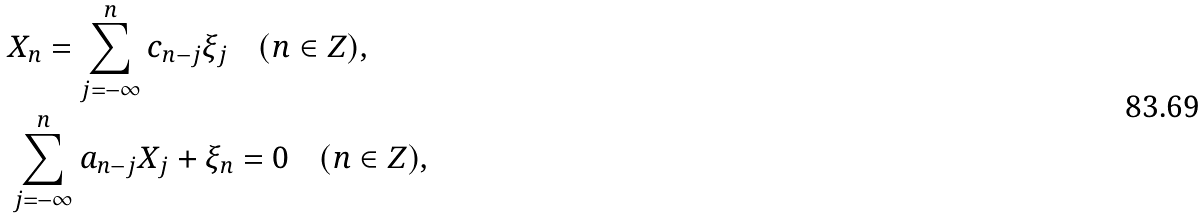<formula> <loc_0><loc_0><loc_500><loc_500>& X _ { n } = \sum _ { j = - \infty } ^ { n } c _ { n - j } \xi _ { j } \quad ( n \in Z ) , \\ & \sum _ { j = - \infty } ^ { n } a _ { n - j } X _ { j } + \xi _ { n } = 0 \quad ( n \in Z ) ,</formula> 